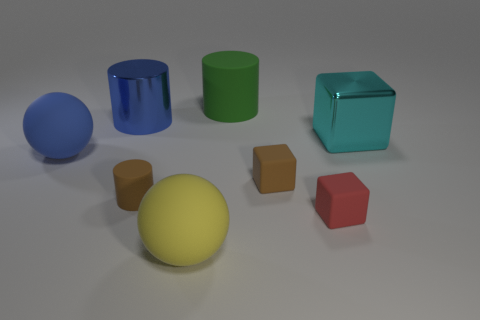Add 1 green objects. How many objects exist? 9 Subtract all cylinders. How many objects are left? 5 Add 7 yellow balls. How many yellow balls are left? 8 Add 6 green metal objects. How many green metal objects exist? 6 Subtract 0 red cylinders. How many objects are left? 8 Subtract all blue balls. Subtract all rubber blocks. How many objects are left? 5 